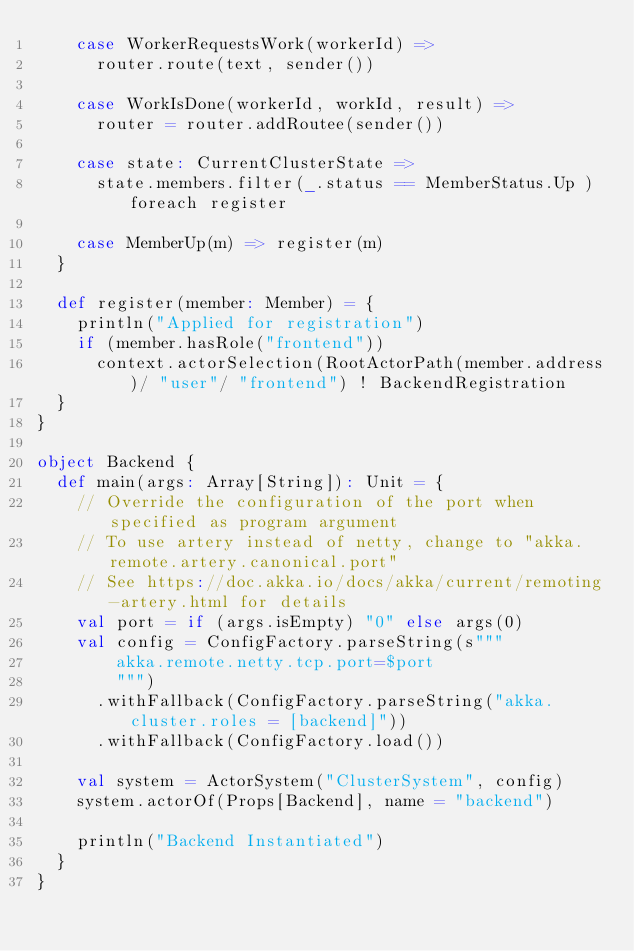Convert code to text. <code><loc_0><loc_0><loc_500><loc_500><_Scala_>    case WorkerRequestsWork(workerId) =>
      router.route(text, sender())

    case WorkIsDone(workerId, workId, result) =>
      router = router.addRoutee(sender())

    case state: CurrentClusterState =>
      state.members.filter(_.status == MemberStatus.Up ) foreach register

    case MemberUp(m) => register(m)
  }

  def register(member: Member) = {
    println("Applied for registration")
    if (member.hasRole("frontend"))
      context.actorSelection(RootActorPath(member.address)/ "user"/ "frontend") ! BackendRegistration
  }
}

object Backend {
  def main(args: Array[String]): Unit = {
    // Override the configuration of the port when specified as program argument
    // To use artery instead of netty, change to "akka.remote.artery.canonical.port"
    // See https://doc.akka.io/docs/akka/current/remoting-artery.html for details
    val port = if (args.isEmpty) "0" else args(0)
    val config = ConfigFactory.parseString(s"""
        akka.remote.netty.tcp.port=$port
        """)
      .withFallback(ConfigFactory.parseString("akka.cluster.roles = [backend]"))
      .withFallback(ConfigFactory.load())

    val system = ActorSystem("ClusterSystem", config)
    system.actorOf(Props[Backend], name = "backend")

    println("Backend Instantiated")
  }
}
</code> 